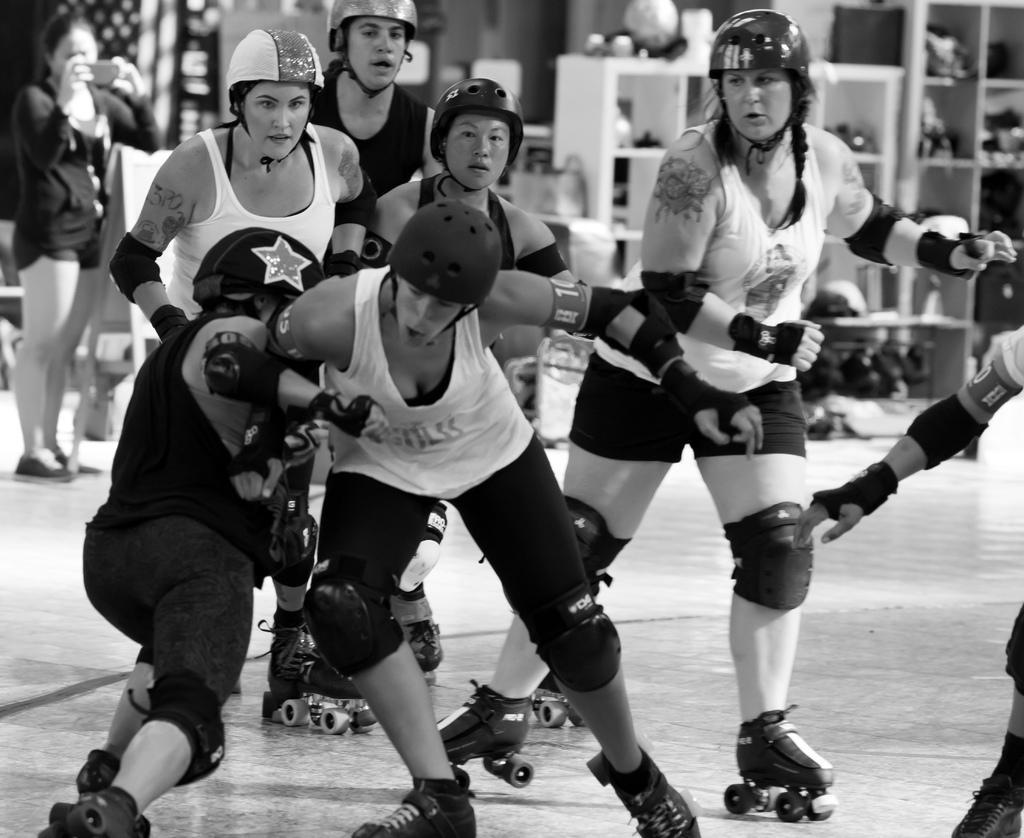How would you summarize this image in a sentence or two? In this image we can see many people playing. There are many objects placed on the racks and few objects are placed on the ground. A person is holding an object at left side of the image. 